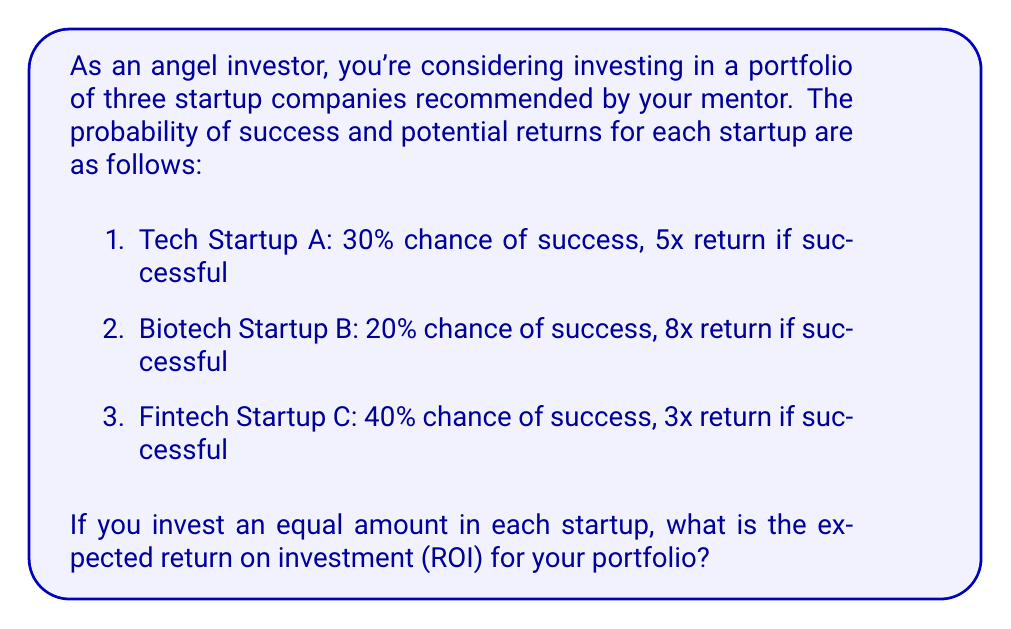Show me your answer to this math problem. Let's approach this step-by-step:

1) First, we need to calculate the expected return for each startup:

   For Startup A:
   $E(A) = 0.30 \times 5 + 0.70 \times 0 = 1.5$

   For Startup B:
   $E(B) = 0.20 \times 8 + 0.80 \times 0 = 1.6$

   For Startup C:
   $E(C) = 0.40 \times 3 + 0.60 \times 0 = 1.2$

2) Since we're investing an equal amount in each startup, the portfolio's expected return is the average of these individual expected returns:

   $E(\text{Portfolio}) = \frac{E(A) + E(B) + E(C)}{3}$

3) Substituting the values:

   $E(\text{Portfolio}) = \frac{1.5 + 1.6 + 1.2}{3} = \frac{4.3}{3} \approx 1.4333$

4) To convert this to a percentage ROI, we subtract 1 (the initial investment) and multiply by 100:

   $\text{ROI} = (1.4333 - 1) \times 100\% = 0.4333 \times 100\% = 43.33\%$

Therefore, the expected ROI for the portfolio is approximately 43.33%.
Answer: 43.33% 